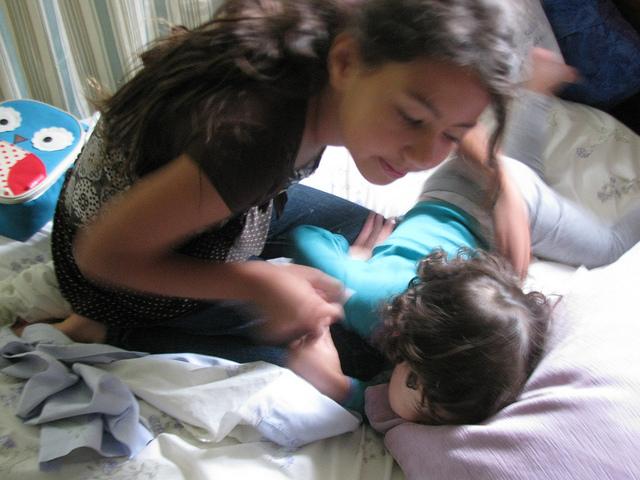Does she love this child?
Be succinct. Yes. Is she trying to put a child to sleep?
Give a very brief answer. Yes. Are the children in this picture standing?
Quick response, please. No. 